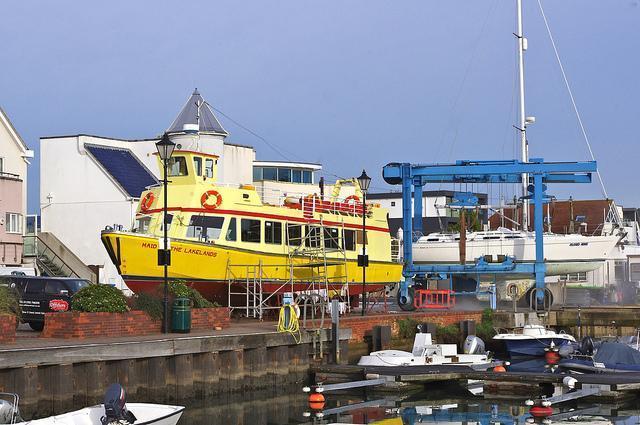How many lamp posts are there?
Give a very brief answer. 2. How many boats are visible?
Give a very brief answer. 3. 